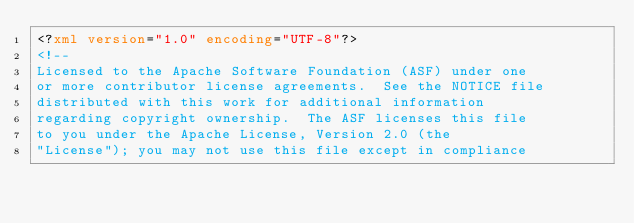<code> <loc_0><loc_0><loc_500><loc_500><_XML_><?xml version="1.0" encoding="UTF-8"?>
<!--
Licensed to the Apache Software Foundation (ASF) under one
or more contributor license agreements.  See the NOTICE file
distributed with this work for additional information
regarding copyright ownership.  The ASF licenses this file
to you under the Apache License, Version 2.0 (the
"License"); you may not use this file except in compliance</code> 